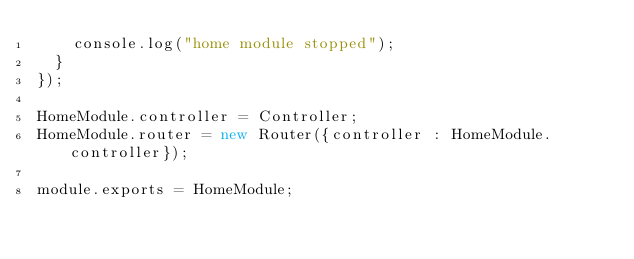<code> <loc_0><loc_0><loc_500><loc_500><_JavaScript_>    console.log("home module stopped");
  }
});

HomeModule.controller = Controller;
HomeModule.router = new Router({controller : HomeModule.controller});

module.exports = HomeModule;
</code> 